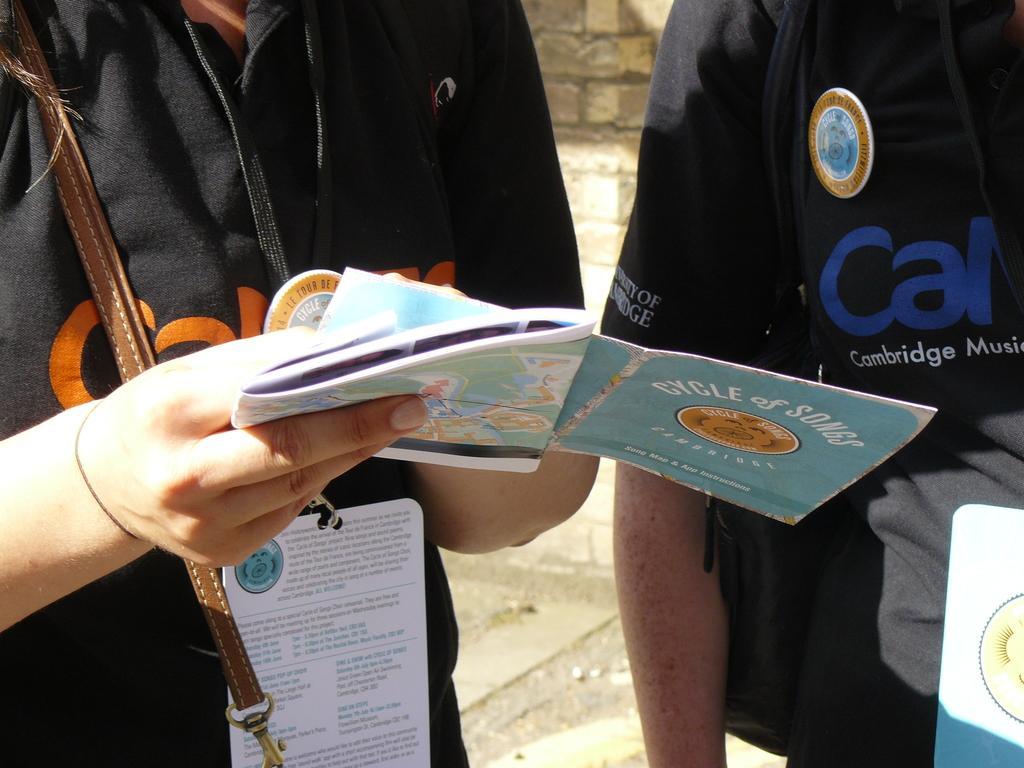In one or two sentences, can you explain what this image depicts? In this picture we can see two people, one person is wearing an id card, holding papers with his hands, here we can see a bag strap, card and in the background we can see the ground, wall. 